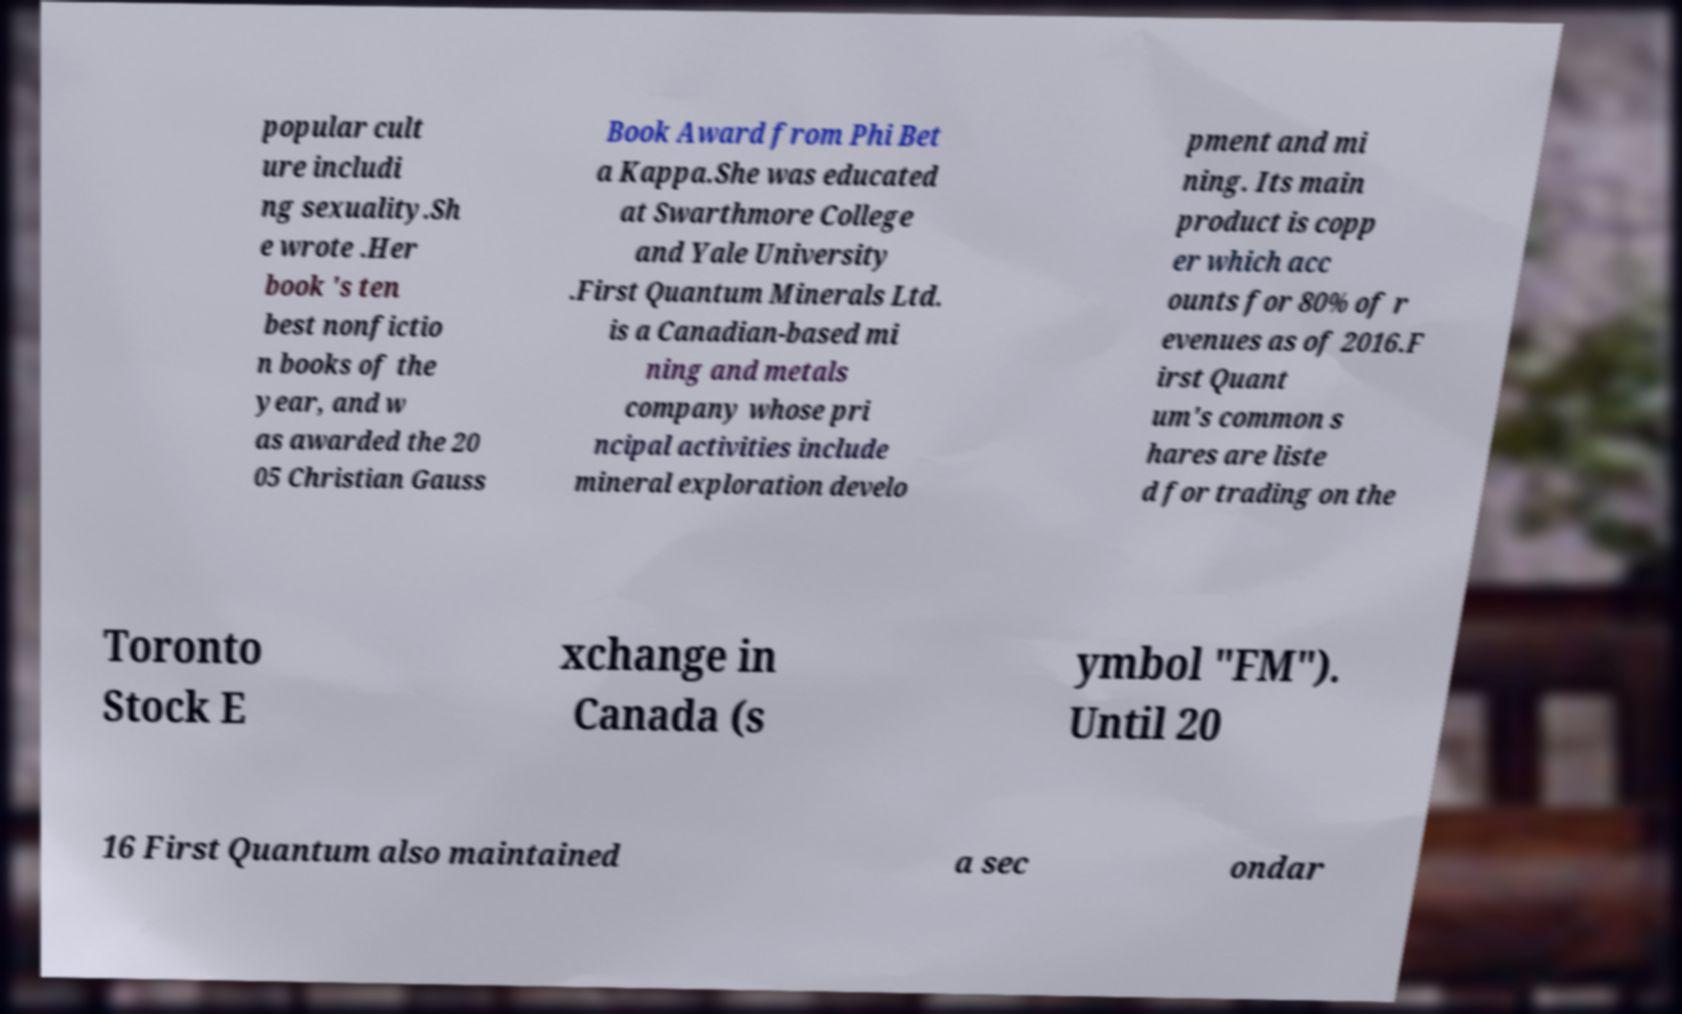For documentation purposes, I need the text within this image transcribed. Could you provide that? popular cult ure includi ng sexuality.Sh e wrote .Her book ′s ten best nonfictio n books of the year, and w as awarded the 20 05 Christian Gauss Book Award from Phi Bet a Kappa.She was educated at Swarthmore College and Yale University .First Quantum Minerals Ltd. is a Canadian-based mi ning and metals company whose pri ncipal activities include mineral exploration develo pment and mi ning. Its main product is copp er which acc ounts for 80% of r evenues as of 2016.F irst Quant um's common s hares are liste d for trading on the Toronto Stock E xchange in Canada (s ymbol "FM"). Until 20 16 First Quantum also maintained a sec ondar 